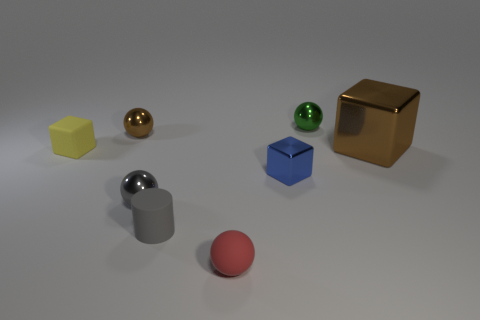Subtract all purple balls. Subtract all green cylinders. How many balls are left? 4 Add 1 small yellow objects. How many objects exist? 9 Subtract all cylinders. How many objects are left? 7 Add 1 large brown objects. How many large brown objects are left? 2 Add 3 tiny green metallic balls. How many tiny green metallic balls exist? 4 Subtract 1 gray cylinders. How many objects are left? 7 Subtract all green objects. Subtract all big brown things. How many objects are left? 6 